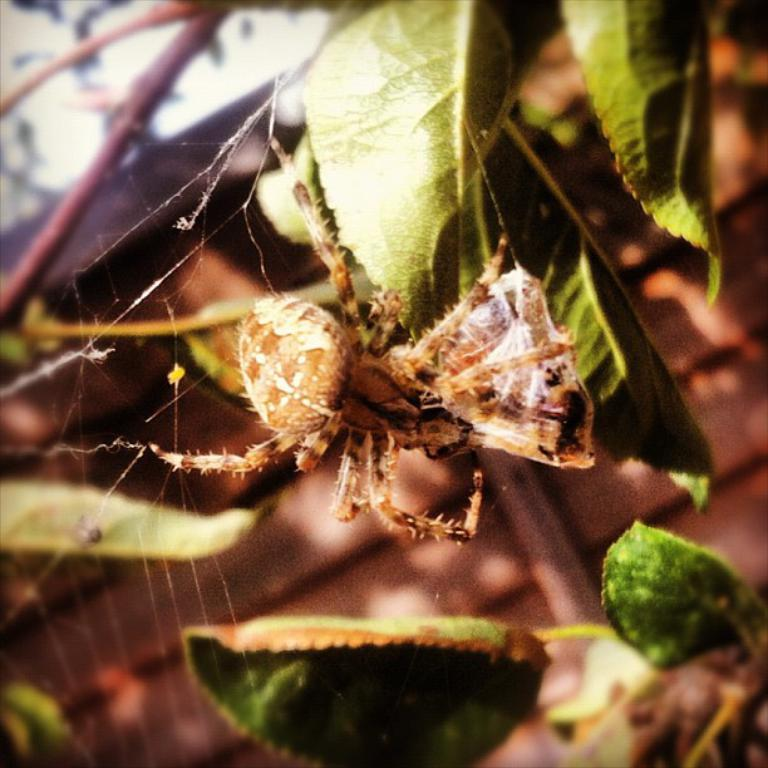What is the main subject of the image? There is a spider in the image. What is the spider associated with in the image? There is a spider web in the image. What type of natural elements can be seen in the image? Leaves are present in the image. Can you describe the background of the image? The background of the image is blurred. What type of silver object is visible in the image? There is no silver object present in the image. What kind of trouble is the spider causing in the image? The image does not depict the spider causing any trouble; it simply shows the spider and its web. 